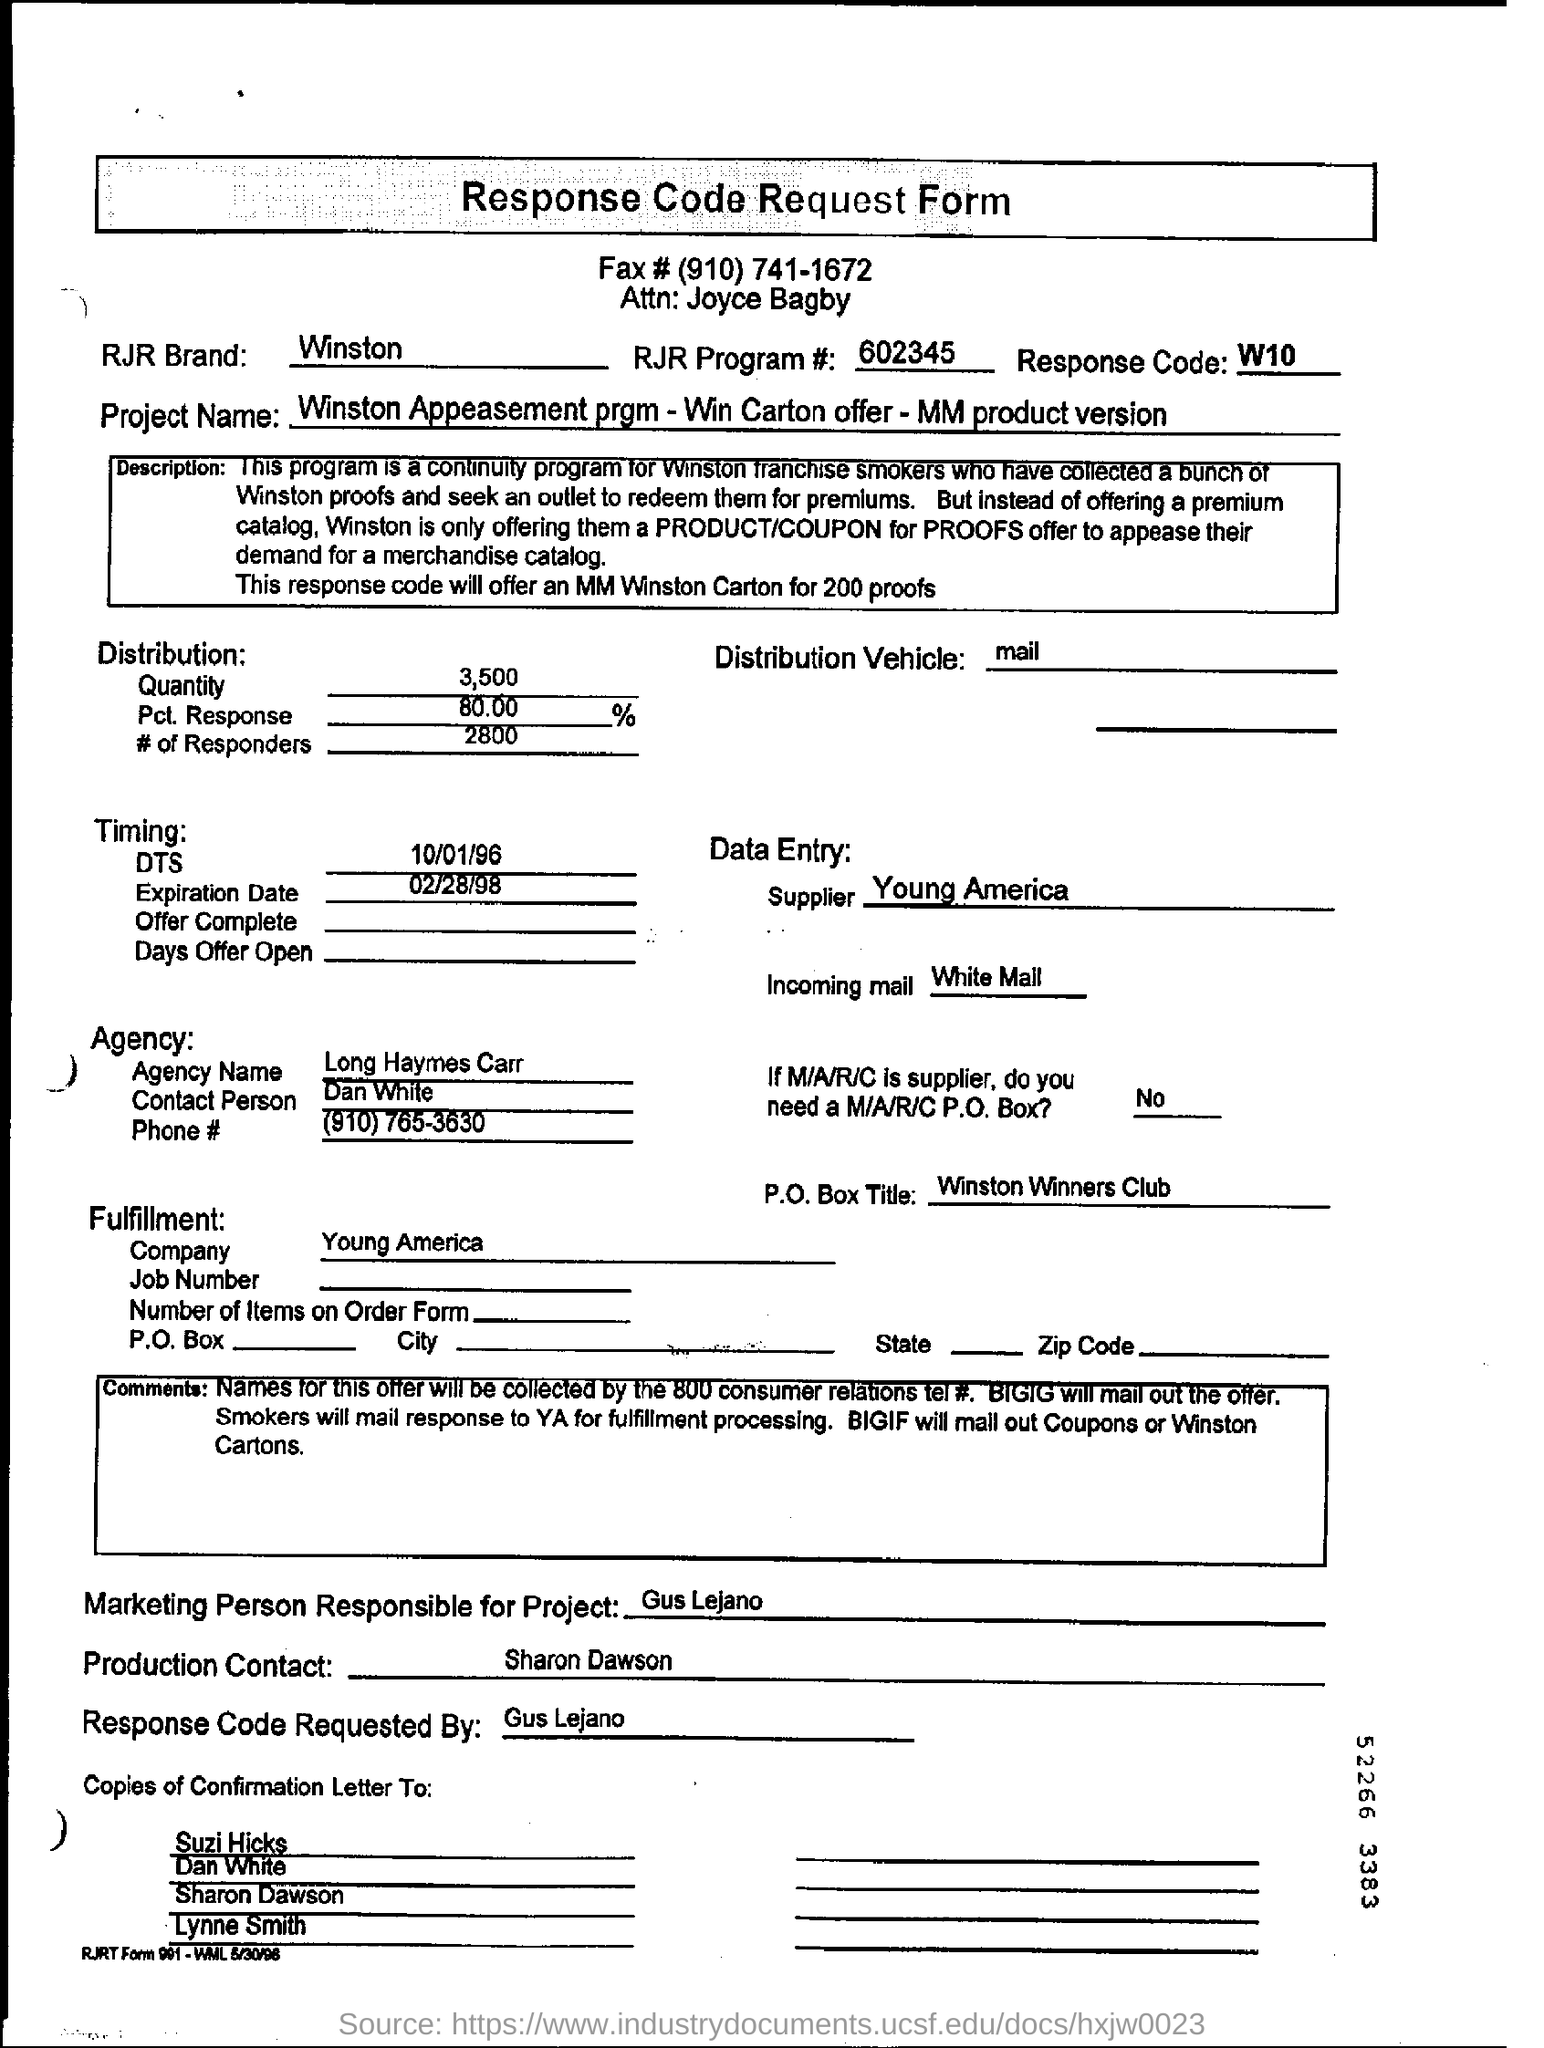What is the name of project?
Provide a succinct answer. Winston Appeasement prgm - Win Carton offer - MM product version. What is the name of the agency ?
Provide a short and direct response. Long Haymes Carr. 